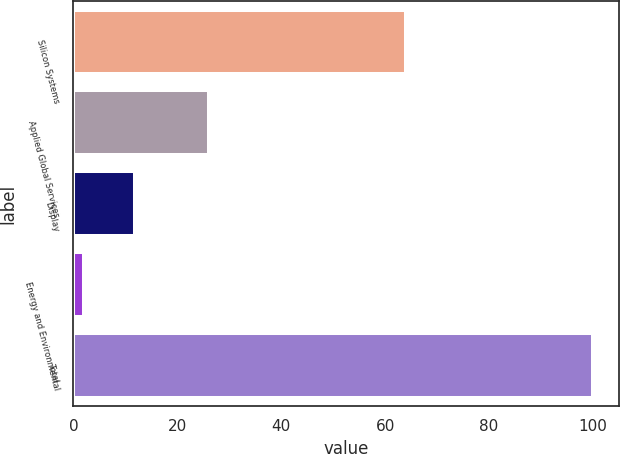Convert chart. <chart><loc_0><loc_0><loc_500><loc_500><bar_chart><fcel>Silicon Systems<fcel>Applied Global Services<fcel>Display<fcel>Energy and Environmental<fcel>Total<nl><fcel>64<fcel>26<fcel>11.8<fcel>2<fcel>100<nl></chart> 